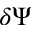Convert formula to latex. <formula><loc_0><loc_0><loc_500><loc_500>\delta \Psi</formula> 